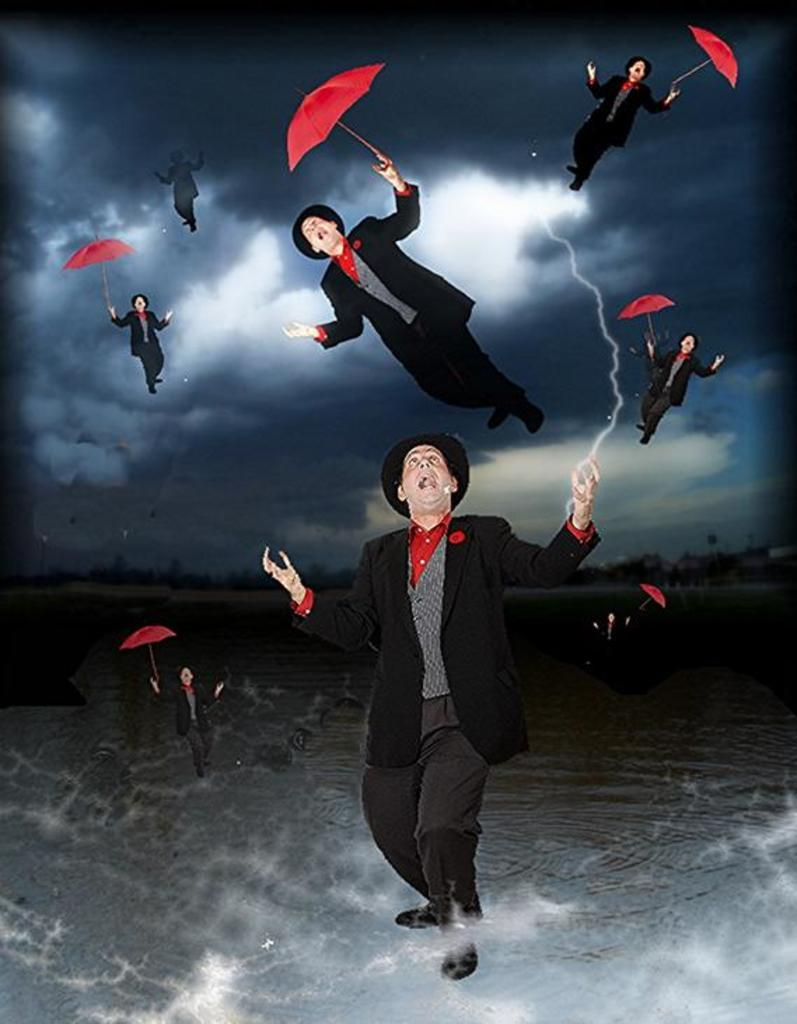What can be said about the nature of the image? The image is edited. Can you describe the person in the image? There is a person in the image. What is the person holding in the image? The person is holding an umbrella. What type of ornament is hanging from the trees in the image? There are no trees or ornaments present in the image. What is the person's opinion about the weather in the image? The image does not provide any information about the person's opinion on the weather. 